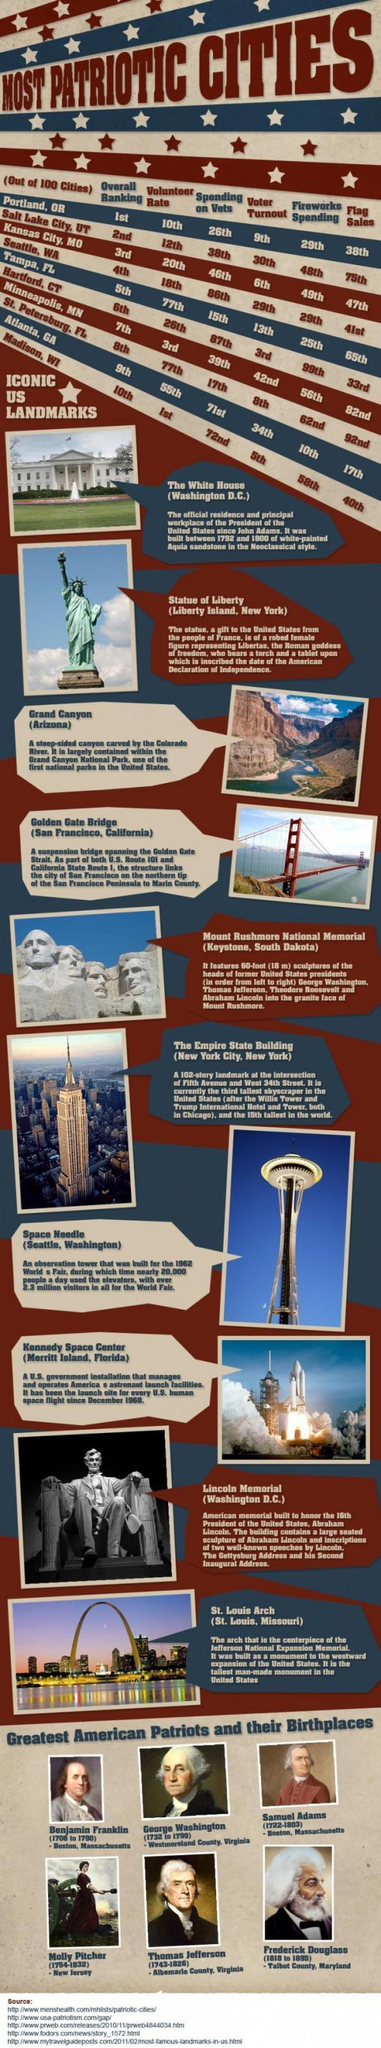Which city is ranked 38th for spending on vets?
Answer the question with a short phrase. Salt Lake City, UT How many sources are given? 5 In which position is Hartford, CT based on voter turnout? 3rd Which is the second landmark from bottom? Lincoln Memorial Where is the third landmark shown located? Arizona What is the position of Atlanta on Volunteer rate? 55th How many iconic US landmarks are shown? 10 